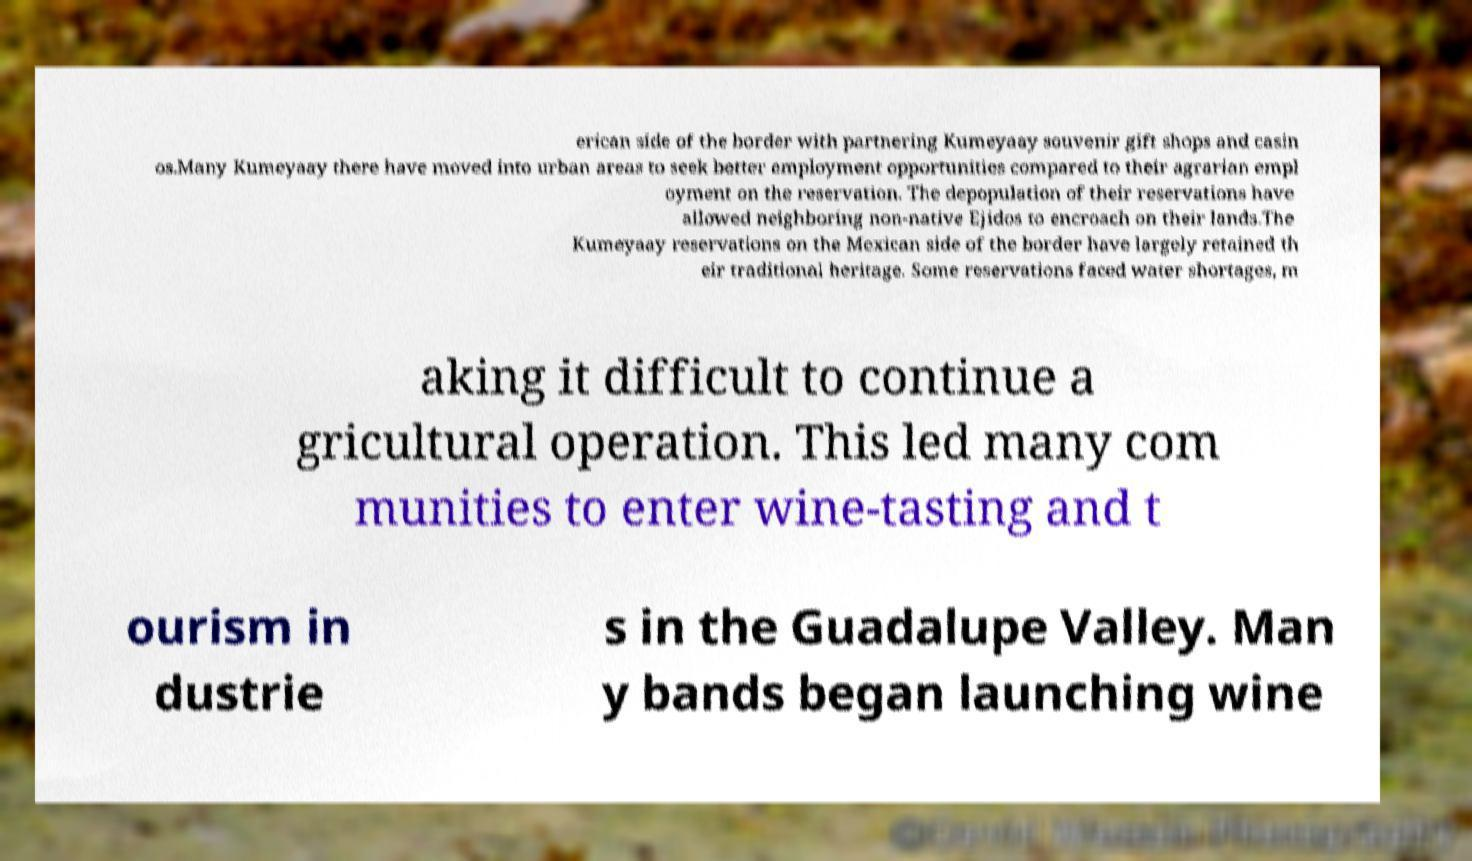Please identify and transcribe the text found in this image. erican side of the border with partnering Kumeyaay souvenir gift shops and casin os.Many Kumeyaay there have moved into urban areas to seek better employment opportunities compared to their agrarian empl oyment on the reservation. The depopulation of their reservations have allowed neighboring non-native Ejidos to encroach on their lands.The Kumeyaay reservations on the Mexican side of the border have largely retained th eir traditional heritage. Some reservations faced water shortages, m aking it difficult to continue a gricultural operation. This led many com munities to enter wine-tasting and t ourism in dustrie s in the Guadalupe Valley. Man y bands began launching wine 